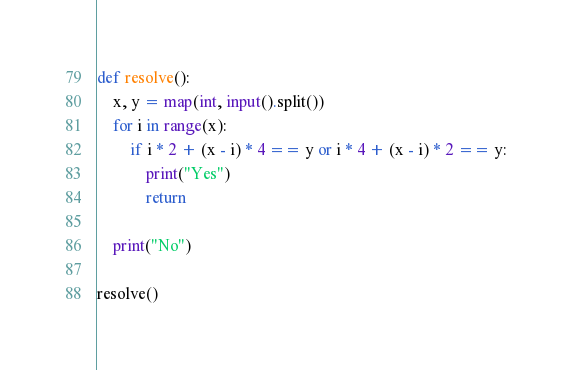Convert code to text. <code><loc_0><loc_0><loc_500><loc_500><_Python_>def resolve():
    x, y = map(int, input().split())
    for i in range(x):
        if i * 2 + (x - i) * 4 == y or i * 4 + (x - i) * 2 == y:
            print("Yes")
            return

    print("No")

resolve()</code> 